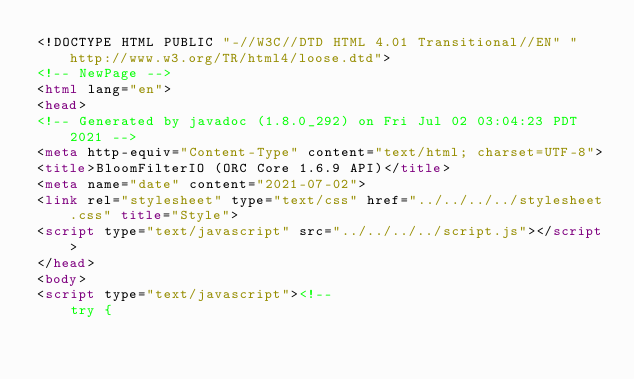Convert code to text. <code><loc_0><loc_0><loc_500><loc_500><_HTML_><!DOCTYPE HTML PUBLIC "-//W3C//DTD HTML 4.01 Transitional//EN" "http://www.w3.org/TR/html4/loose.dtd">
<!-- NewPage -->
<html lang="en">
<head>
<!-- Generated by javadoc (1.8.0_292) on Fri Jul 02 03:04:23 PDT 2021 -->
<meta http-equiv="Content-Type" content="text/html; charset=UTF-8">
<title>BloomFilterIO (ORC Core 1.6.9 API)</title>
<meta name="date" content="2021-07-02">
<link rel="stylesheet" type="text/css" href="../../../../stylesheet.css" title="Style">
<script type="text/javascript" src="../../../../script.js"></script>
</head>
<body>
<script type="text/javascript"><!--
    try {</code> 